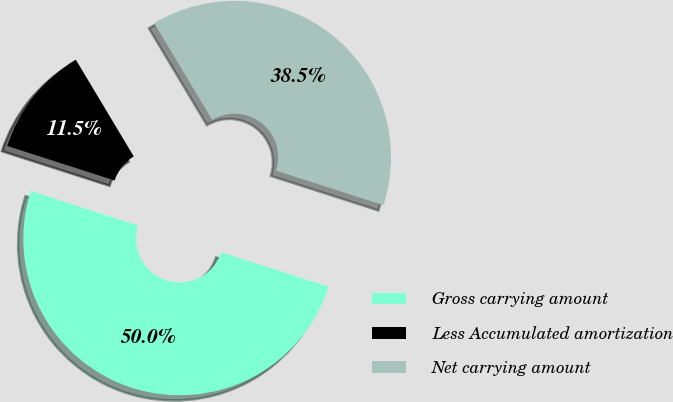Convert chart. <chart><loc_0><loc_0><loc_500><loc_500><pie_chart><fcel>Gross carrying amount<fcel>Less Accumulated amortization<fcel>Net carrying amount<nl><fcel>50.0%<fcel>11.46%<fcel>38.54%<nl></chart> 